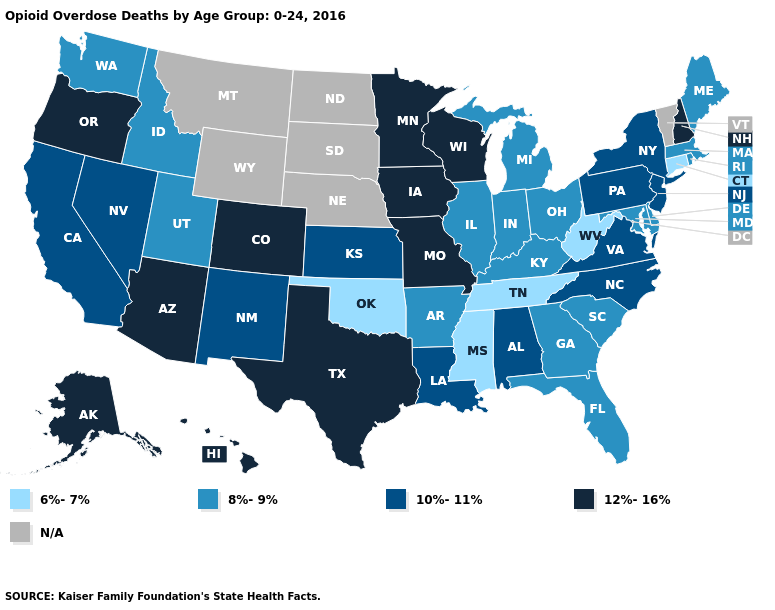What is the value of Wisconsin?
Concise answer only. 12%-16%. Which states have the highest value in the USA?
Write a very short answer. Alaska, Arizona, Colorado, Hawaii, Iowa, Minnesota, Missouri, New Hampshire, Oregon, Texas, Wisconsin. Among the states that border Georgia , does South Carolina have the lowest value?
Short answer required. No. What is the lowest value in states that border Iowa?
Short answer required. 8%-9%. What is the value of New Mexico?
Write a very short answer. 10%-11%. Which states have the highest value in the USA?
Keep it brief. Alaska, Arizona, Colorado, Hawaii, Iowa, Minnesota, Missouri, New Hampshire, Oregon, Texas, Wisconsin. What is the lowest value in the USA?
Short answer required. 6%-7%. Among the states that border West Virginia , which have the lowest value?
Answer briefly. Kentucky, Maryland, Ohio. What is the value of Louisiana?
Give a very brief answer. 10%-11%. Name the states that have a value in the range 10%-11%?
Short answer required. Alabama, California, Kansas, Louisiana, Nevada, New Jersey, New Mexico, New York, North Carolina, Pennsylvania, Virginia. Does Maryland have the highest value in the USA?
Short answer required. No. Name the states that have a value in the range 8%-9%?
Concise answer only. Arkansas, Delaware, Florida, Georgia, Idaho, Illinois, Indiana, Kentucky, Maine, Maryland, Massachusetts, Michigan, Ohio, Rhode Island, South Carolina, Utah, Washington. What is the value of Georgia?
Answer briefly. 8%-9%. Name the states that have a value in the range N/A?
Concise answer only. Montana, Nebraska, North Dakota, South Dakota, Vermont, Wyoming. 